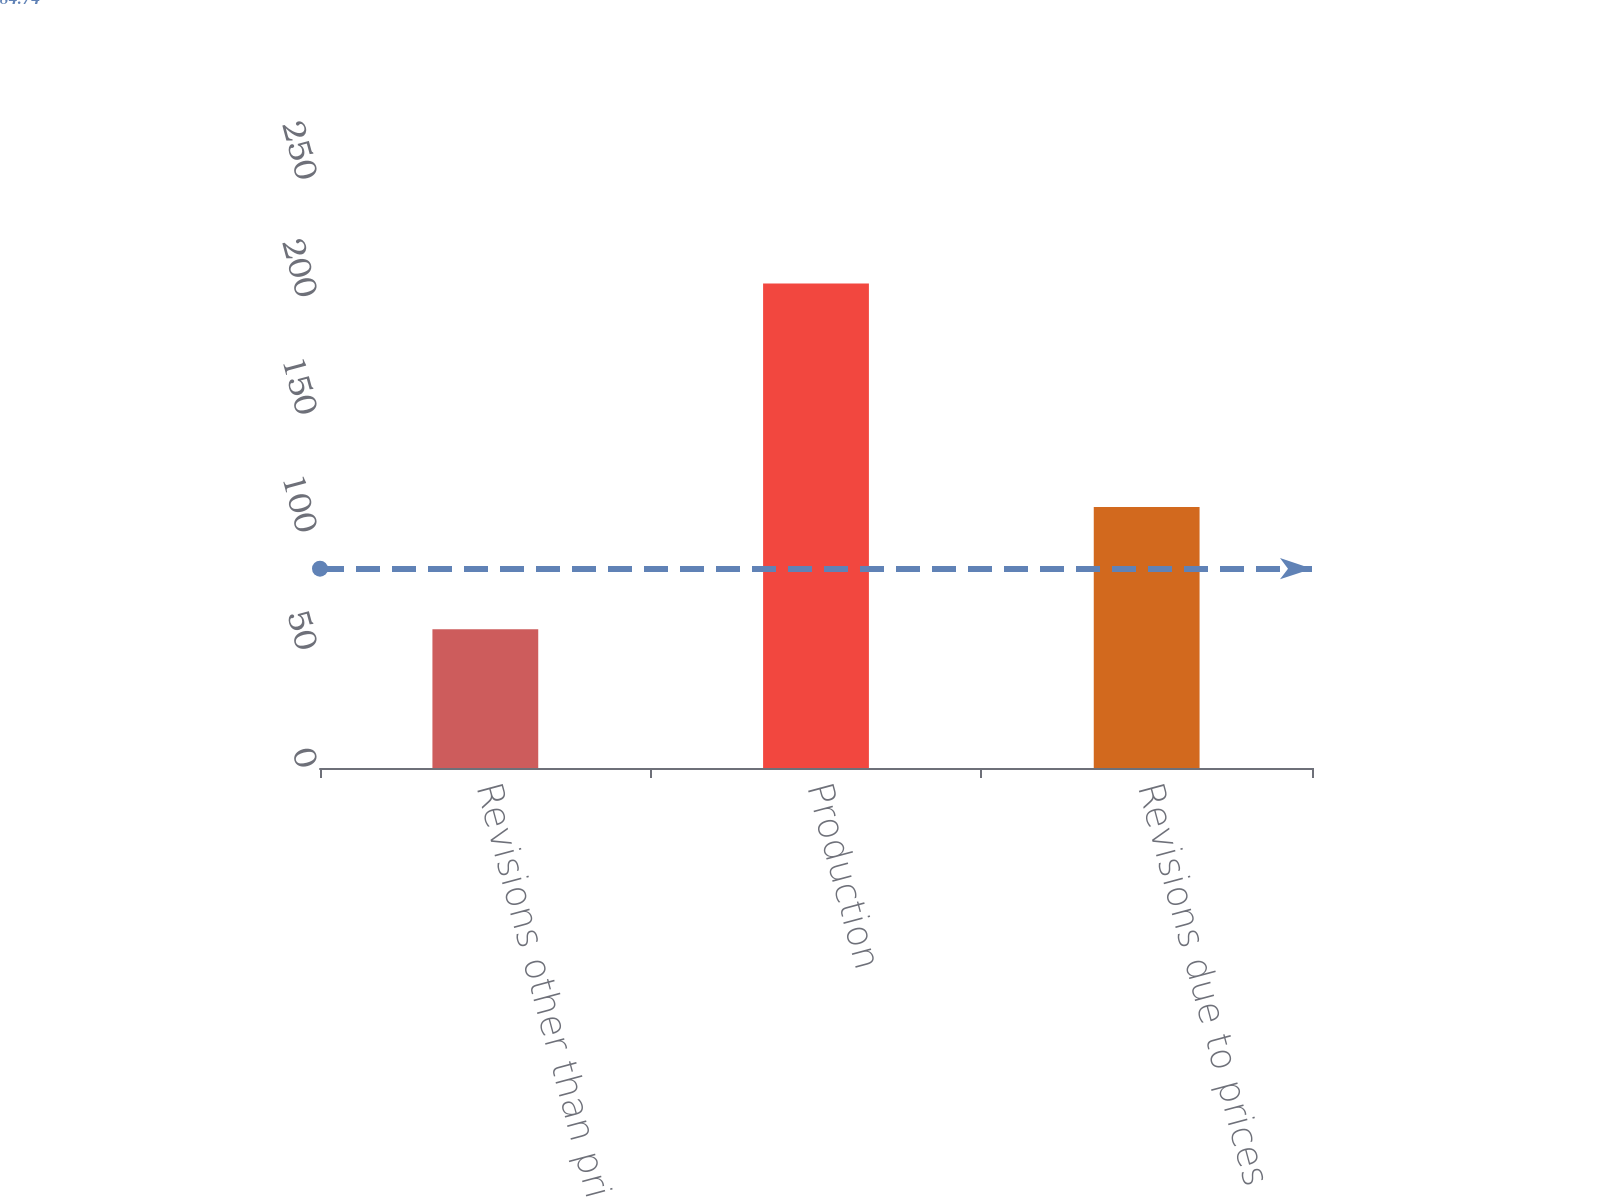Convert chart. <chart><loc_0><loc_0><loc_500><loc_500><bar_chart><fcel>Revisions other than price<fcel>Production<fcel>Revisions due to prices<nl><fcel>59<fcel>206<fcel>111<nl></chart> 